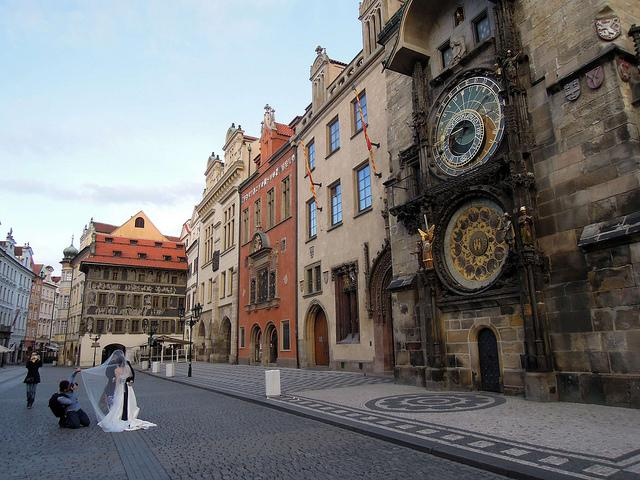What occasion is now photographed underneath the clock faces?

Choices:
A) sale
B) realty
C) insurance
D) marriage marriage 